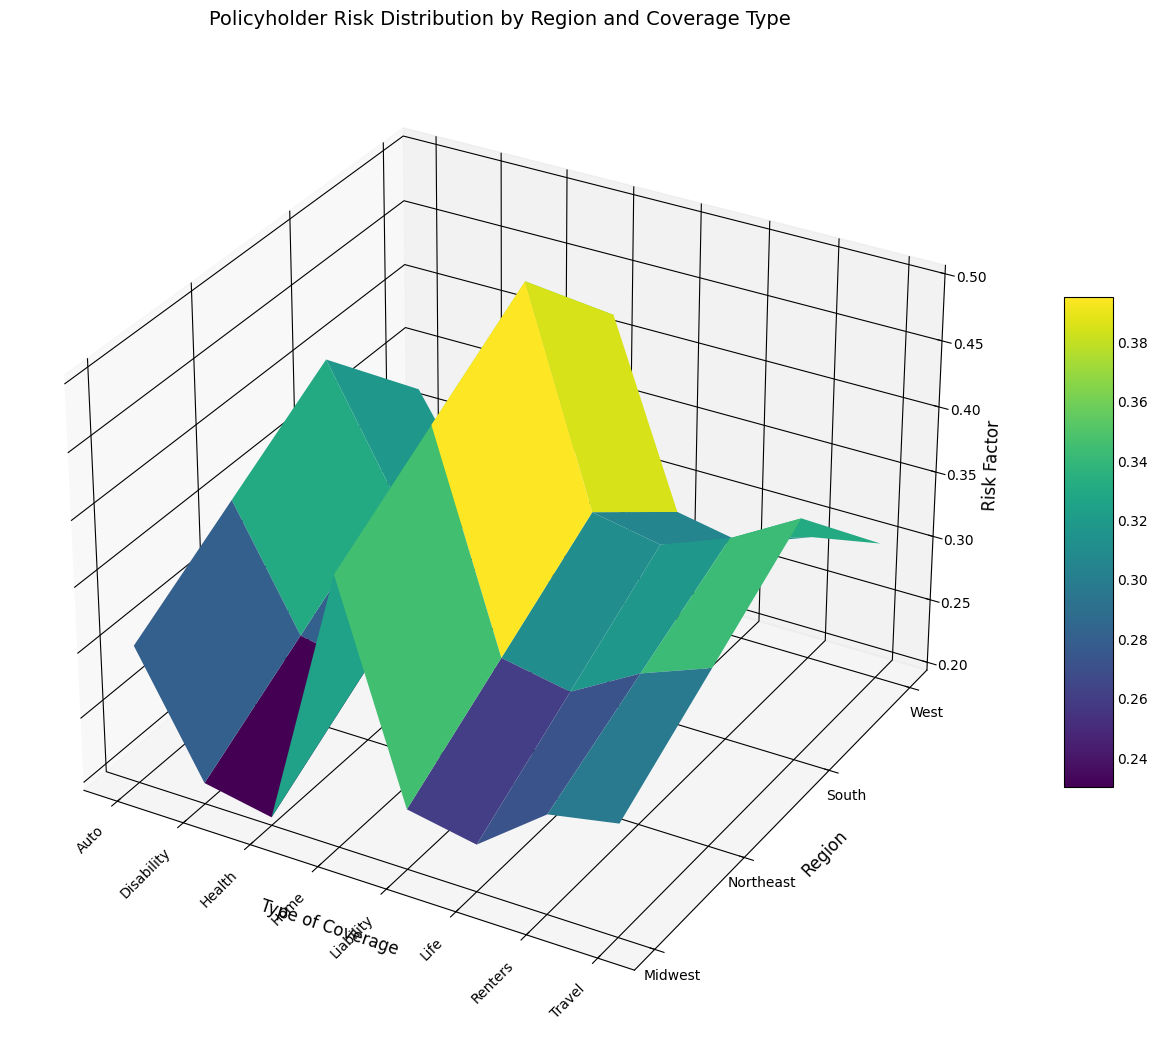Which region has the highest risk factor for Home coverage? Observe the highest peak in the plot corresponding to Home coverage. The tallest one is in the South region.
Answer: South What is the difference in risk factor for Life coverage between the Northeast and Midwest regions? Locate the bars for Life coverage in both the Northeast and Midwest regions and compare their heights. The Northeast is at 0.28 and the Midwest is at 0.23.
Answer: 0.05 Which type of coverage has the most consistent risk factor across the regions? Look for the coverage type with bars of nearly equal height across all regions. Disability coverage has little variation across the regions (0.26 in Northeast, 0.21 in Midwest, 0.31 in South, 0.24 in West).
Answer: Disability Between Health and Auto coverage in the West, which has a lower risk factor? Compare the heights of the Health and Auto bars in the West region. Health is at 0.22, and Auto is at 0.32.
Answer: Health What is the average risk factor for Renters coverage across all regions? Calculate the average of the risk factors for Renters coverage in all the regions: (0.31 + 0.27 + 0.35 + 0.29) / 4 = 0.30
Answer: 0.30 How does the risk factor for Travel coverage in the South compare to that in the West? Observe the heights of the Travel coverage bars in both regions. The South has a higher risk factor (0.38) compared to the West (0.30).
Answer: South > West What is the combined risk factor for Policyholder Risk Distribution in the Midwest for Auto, Home, and Life coverages? Sum the heights of the bars for Auto (0.30), Home (0.40), and Life (0.23) coverages in the Midwest.
Answer: 0.93 What is the relative difference in risk factor for Liability coverage between the Northeast and the West? Find the difference and then divide it by the risk factor in the West to get the relative difference. Relative difference formula: (0.29 - 0.28) / 0.28 = 0.0357
Answer: 0.0357 Which region shows the highest risk factor for travel coverage? Look for the highest peak in the Travel coverage category. The South has the highest risk factor for Travel at 0.38.
Answer: South 